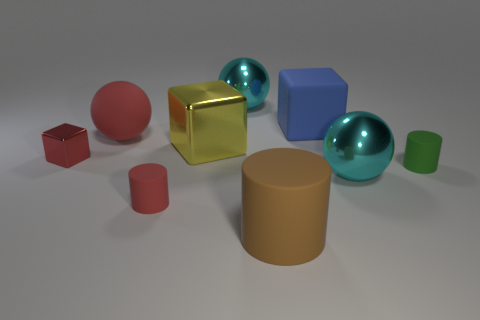There is a tiny cylinder that is the same color as the tiny shiny block; what is its material?
Offer a very short reply. Rubber. Is the color of the big matte cylinder the same as the matte sphere?
Provide a short and direct response. No. How many other objects are there of the same color as the big rubber cylinder?
Provide a short and direct response. 0. What shape is the green thing that is on the right side of the big brown matte cylinder that is on the right side of the small red cube?
Make the answer very short. Cylinder. How many big cyan shiny things are on the left side of the small red cube?
Keep it short and to the point. 0. Are there any large cyan spheres made of the same material as the blue cube?
Keep it short and to the point. No. There is a cylinder that is the same size as the blue thing; what is it made of?
Give a very brief answer. Rubber. There is a block that is both on the left side of the large brown rubber object and to the right of the red shiny block; how big is it?
Give a very brief answer. Large. There is a thing that is both in front of the yellow metallic thing and to the left of the red cylinder; what color is it?
Make the answer very short. Red. Are there fewer cubes that are to the left of the tiny red cylinder than small green rubber objects on the left side of the small green cylinder?
Provide a short and direct response. No. 